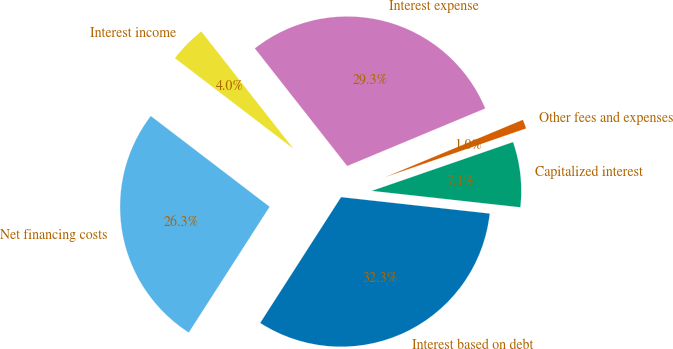Convert chart. <chart><loc_0><loc_0><loc_500><loc_500><pie_chart><fcel>Interest based on debt<fcel>Capitalized interest<fcel>Other fees and expenses<fcel>Interest expense<fcel>Interest income<fcel>Net financing costs<nl><fcel>32.34%<fcel>7.05%<fcel>0.99%<fcel>29.31%<fcel>4.02%<fcel>26.29%<nl></chart> 